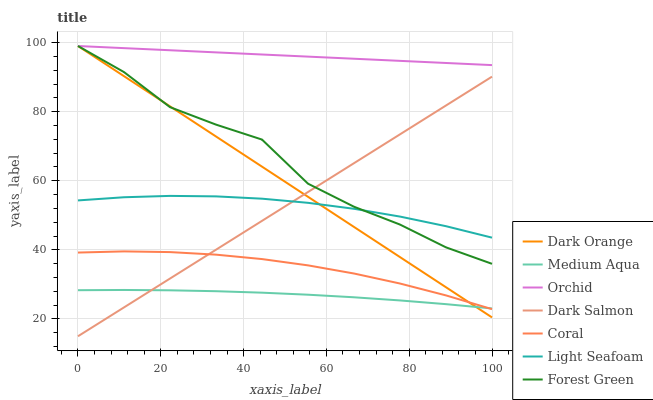Does Medium Aqua have the minimum area under the curve?
Answer yes or no. Yes. Does Orchid have the maximum area under the curve?
Answer yes or no. Yes. Does Coral have the minimum area under the curve?
Answer yes or no. No. Does Coral have the maximum area under the curve?
Answer yes or no. No. Is Dark Salmon the smoothest?
Answer yes or no. Yes. Is Forest Green the roughest?
Answer yes or no. Yes. Is Coral the smoothest?
Answer yes or no. No. Is Coral the roughest?
Answer yes or no. No. Does Dark Salmon have the lowest value?
Answer yes or no. Yes. Does Coral have the lowest value?
Answer yes or no. No. Does Orchid have the highest value?
Answer yes or no. Yes. Does Coral have the highest value?
Answer yes or no. No. Is Dark Salmon less than Orchid?
Answer yes or no. Yes. Is Light Seafoam greater than Medium Aqua?
Answer yes or no. Yes. Does Dark Salmon intersect Light Seafoam?
Answer yes or no. Yes. Is Dark Salmon less than Light Seafoam?
Answer yes or no. No. Is Dark Salmon greater than Light Seafoam?
Answer yes or no. No. Does Dark Salmon intersect Orchid?
Answer yes or no. No. 